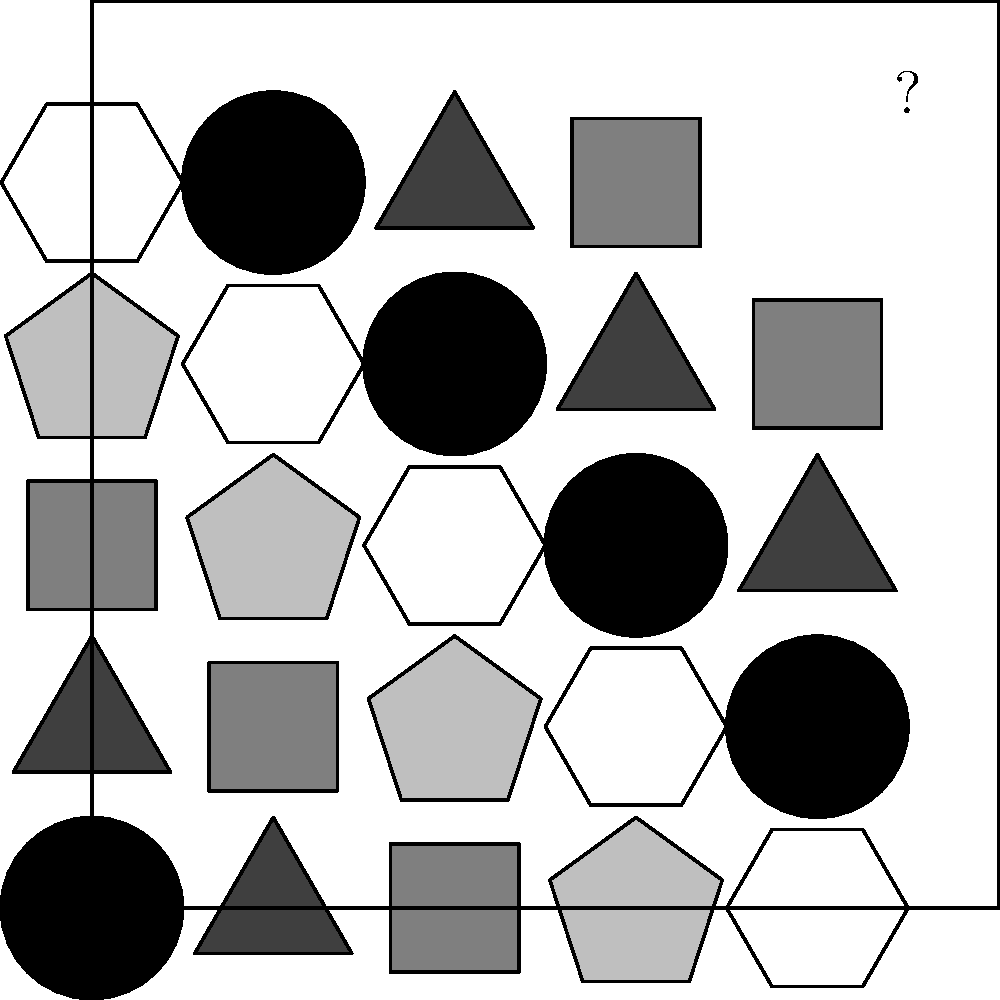Which shape belongs in the empty space marked with a question mark? To solve this puzzle, we need to identify the pattern:

1. Each row and column contains all five shapes: circle, triangle, square, pentagon, and hexagon.
2. The shading of each shape follows a gradient from light to dark.
3. The shapes are arranged diagonally, repeating every 5 cells.

To determine the missing shape:

1. Look at the shapes in the same column (top to bottom): hexagon, pentagon, square, triangle.
2. Look at the shapes in the same row (left to right): pentagon, hexagon, circle, square.
3. The missing shape should complete both the column and row without repetition.
4. The only shape not present in either the column or row is the circle.
5. The shading should be the darkest in the sequence.

Therefore, the missing shape is a dark circle.
Answer: Dark circle 